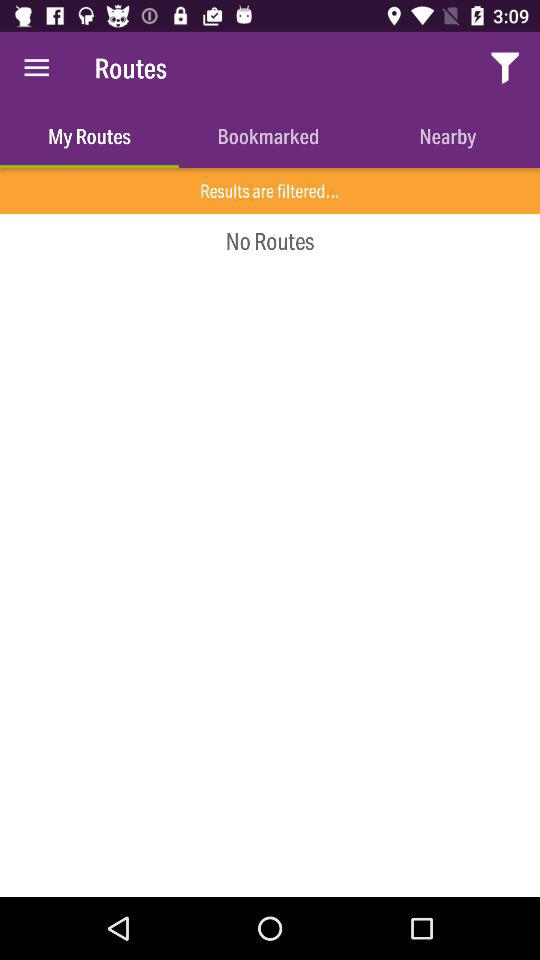What is the app name? The app name is "Routes". 